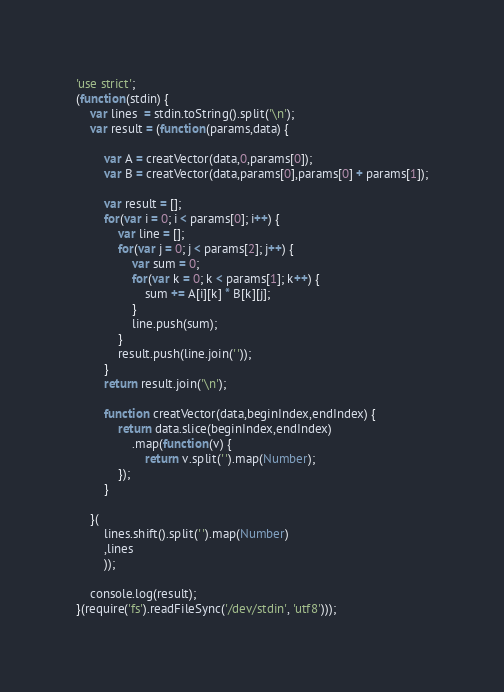Convert code to text. <code><loc_0><loc_0><loc_500><loc_500><_JavaScript_>'use strict';
(function(stdin) {
	var lines  = stdin.toString().split('\n');
	var result = (function(params,data) {

		var A = creatVector(data,0,params[0]);
		var B = creatVector(data,params[0],params[0] + params[1]);

		var result = [];
		for(var i = 0; i < params[0]; i++) {
			var line = [];
			for(var j = 0; j < params[2]; j++) {
				var sum = 0;
				for(var k = 0; k < params[1]; k++) {
					sum += A[i][k] * B[k][j];
				}
				line.push(sum);
			}
			result.push(line.join(' '));
		}
		return result.join('\n');

		function creatVector(data,beginIndex,endIndex) {
			return data.slice(beginIndex,endIndex)
				.map(function(v) { 
					return v.split(' ').map(Number);
			});
		}

	}(
		lines.shift().split(' ').map(Number)
		,lines
		));

	console.log(result);
}(require('fs').readFileSync('/dev/stdin', 'utf8')));</code> 